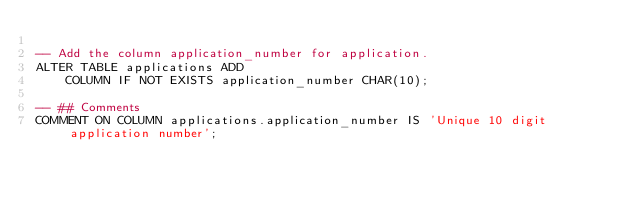Convert code to text. <code><loc_0><loc_0><loc_500><loc_500><_SQL_>
-- Add the column application_number for application.
ALTER TABLE applications ADD 
    COLUMN IF NOT EXISTS application_number CHAR(10);

-- ## Comments
COMMENT ON COLUMN applications.application_number IS 'Unique 10 digit application number';
</code> 